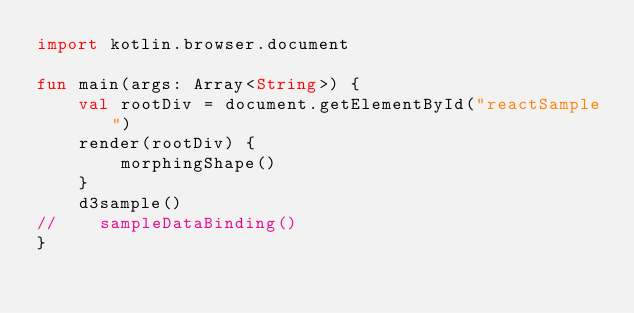Convert code to text. <code><loc_0><loc_0><loc_500><loc_500><_Kotlin_>import kotlin.browser.document

fun main(args: Array<String>) {
    val rootDiv = document.getElementById("reactSample")
    render(rootDiv) {
        morphingShape()
    }
    d3sample()
//    sampleDataBinding()
}


</code> 